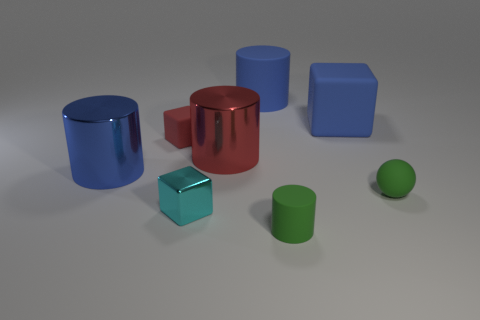Are there any matte cylinders that have the same color as the tiny rubber ball?
Keep it short and to the point. Yes. What is the shape of the tiny cyan thing that is in front of the rubber cube that is on the right side of the small green rubber object left of the small green ball?
Ensure brevity in your answer.  Cube. What number of balls are large shiny things or blue objects?
Your answer should be very brief. 0. There is a object that is behind the big rubber cube; does it have the same color as the shiny cube?
Your answer should be very brief. No. The large blue object right of the matte cylinder on the right side of the big blue cylinder behind the large blue metal cylinder is made of what material?
Make the answer very short. Rubber. Does the blue metallic thing have the same size as the cyan metal thing?
Keep it short and to the point. No. There is a metallic cube; is its color the same as the rubber thing that is to the right of the blue matte cube?
Your response must be concise. No. What is the shape of the blue thing that is made of the same material as the red cylinder?
Your answer should be compact. Cylinder. There is a blue thing that is in front of the tiny red matte cube; is its shape the same as the big red thing?
Provide a succinct answer. Yes. What size is the metallic thing that is behind the blue thing in front of the red cylinder?
Offer a very short reply. Large. 